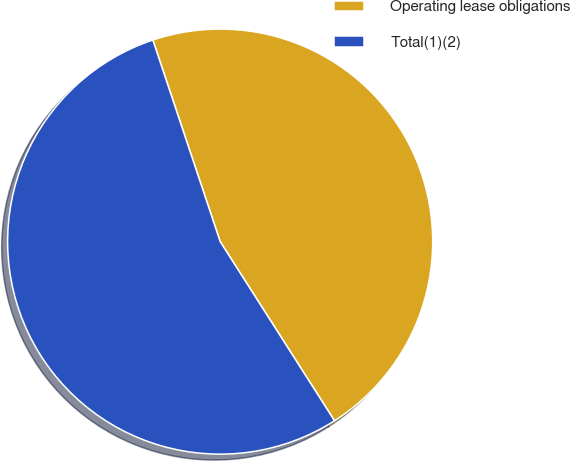Convert chart. <chart><loc_0><loc_0><loc_500><loc_500><pie_chart><fcel>Operating lease obligations<fcel>Total(1)(2)<nl><fcel>46.09%<fcel>53.91%<nl></chart> 